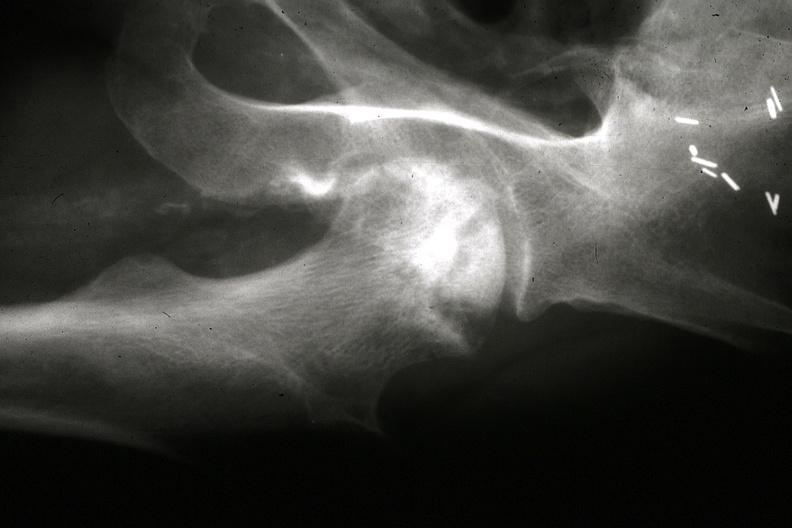what is present?
Answer the question using a single word or phrase. Joints 